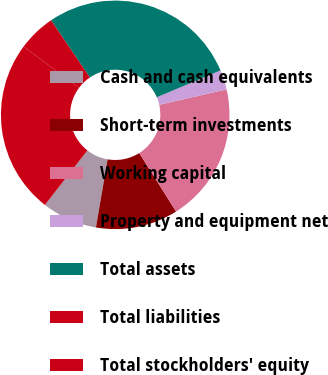Convert chart. <chart><loc_0><loc_0><loc_500><loc_500><pie_chart><fcel>Cash and cash equivalents<fcel>Short-term investments<fcel>Working capital<fcel>Property and equipment net<fcel>Total assets<fcel>Total liabilities<fcel>Total stockholders' equity<nl><fcel>7.85%<fcel>11.64%<fcel>19.63%<fcel>2.78%<fcel>28.13%<fcel>5.31%<fcel>24.65%<nl></chart> 